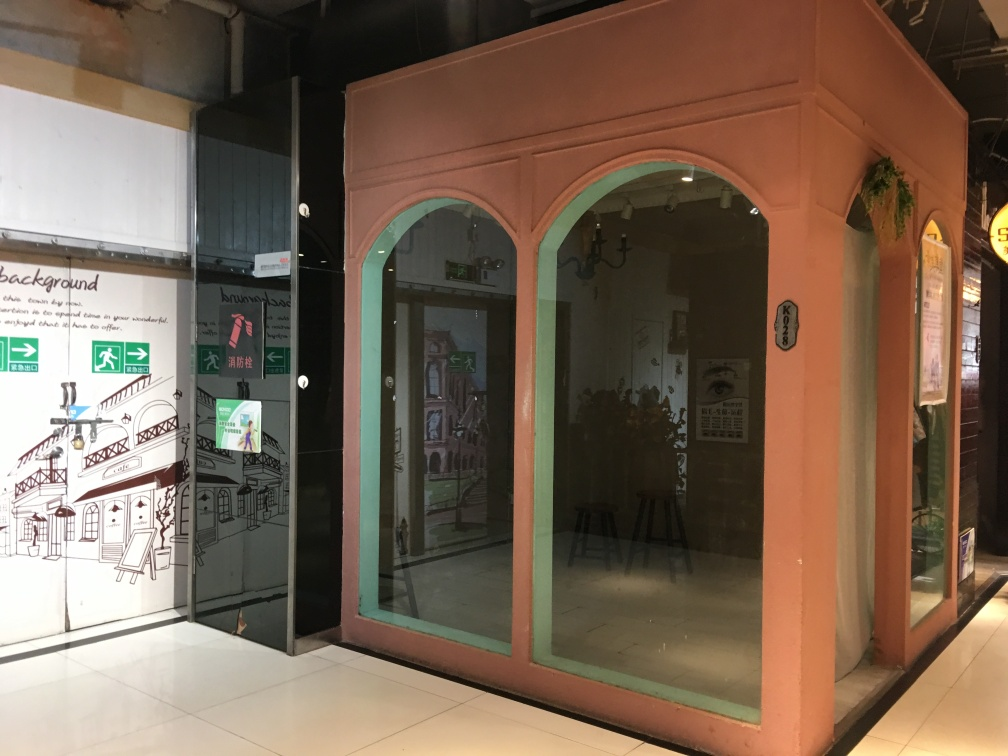How would you describe the sharpness of this photo? The sharpness of the photo is moderate; while the details in the foreground are relatively clear, such as the texture of the pink wall and the lettering on the windows, there's a slight softness especially noticeable in the objects further back. The indoor lights and reflection on the glass add a bit of glare, which could affect the perceived sharpness. 